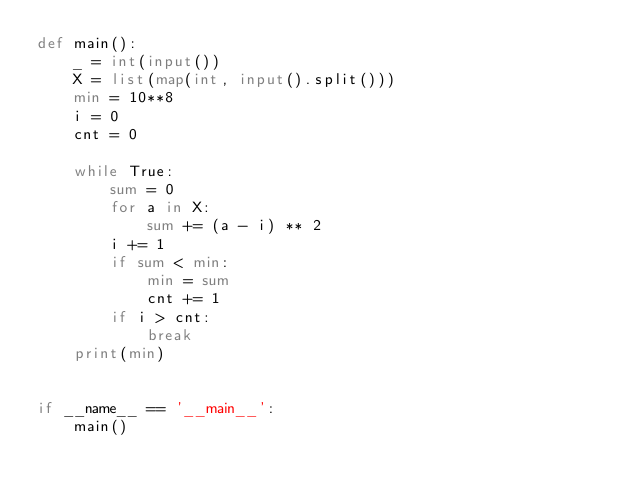<code> <loc_0><loc_0><loc_500><loc_500><_Python_>def main():
    _ = int(input())
    X = list(map(int, input().split()))
    min = 10**8
    i = 0
    cnt = 0

    while True:
        sum = 0
        for a in X:
            sum += (a - i) ** 2
        i += 1
        if sum < min:
            min = sum
            cnt += 1
        if i > cnt:
            break
    print(min)


if __name__ == '__main__':
    main()
</code> 